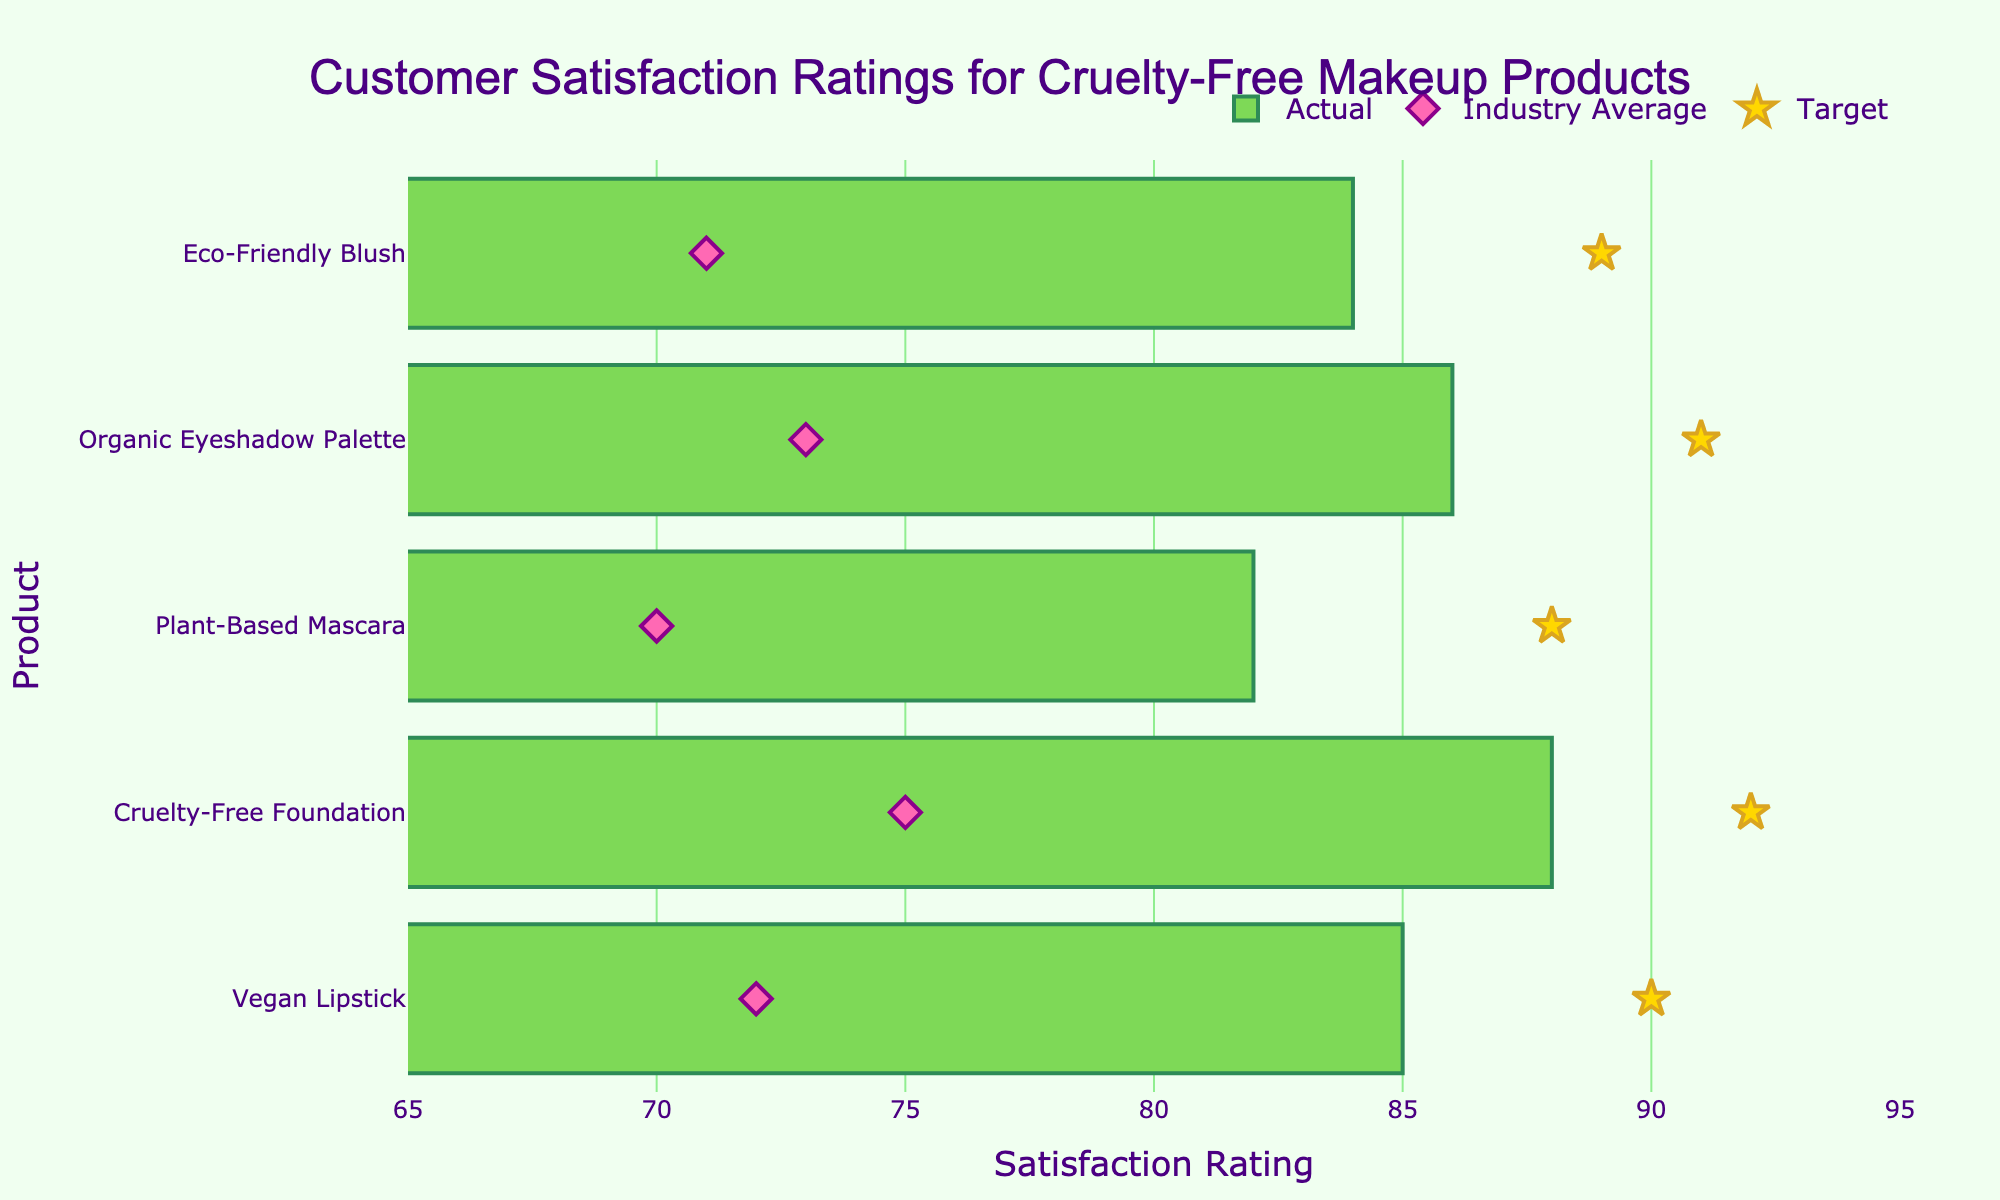What's the title of the figure? The title is usually located at the top center of the figure. It helps identify the main subject of the chart. In this case, it is "Customer Satisfaction Ratings for Cruelty-Free Makeup Products".
Answer: Customer Satisfaction Ratings for Cruelty-Free Makeup Products What is the highest actual satisfaction rating among the products? To find the highest actual satisfaction rating, we need to look at the longest bar in the chart, which corresponds to the "Cruelty-Free Foundation" with a rating of 88.
Answer: 88 Which product has the lowest industry average satisfaction rating? The industry average satisfaction ratings are represented by the diamond markers in the figure. The lowest marker is for "Plant-Based Mascara" with a rating of 70.
Answer: Plant-Based Mascara How does the satisfaction rating of Vegan Lipstick compare to its target? We can compare the actual bar height (85) and the star marker (90) to see that the satisfaction rating for Vegan Lipstick is slightly below its target.
Answer: Below target by 5 points Which product has the smallest gap between its actual satisfaction rating and its target? To determine the smallest gap, we calculate the absolute differences between the actual ratings and the target ratings for each product. The smallest difference is 3 points for "Eco-Friendly Blush" (84 actual vs. 89 target).
Answer: Eco-Friendly Blush What is the average actual satisfaction rating of the products? Adding up all the actual ratings (85, 88, 82, 86, 84) gives us 425. Dividing by the number of products (5) gives an average of 85.
Answer: 85 Which product's industry average is closest to its target? Compare the industry averages (diamond markers) to the target markers (stars) and find the smallest difference. "Plant-Based Mascara" has a rating of 70 (industry average) and 88 (target), which is an 18-point difference, the closest among all products.
Answer: Plant-Based Mascara How many products have an actual satisfaction rating above the industry average? Count the bars whose lengths (actual ratings) are above the respective diamond markers (industry averages). All products (Vegan Lipstick, Cruelty-Free Foundation, Plant-Based Mascara, Organic Eyeshadow Palette, Eco-Friendly Blush) have higher actual ratings than the industry average.
Answer: 5 Which product needs the most improvement to meet its target? The product with the largest gap between its actual satisfaction rating and target is "Plant-Based Mascara" (82 actual vs. 88 target), needing an improvement of 6 points.
Answer: Plant-Based Mascara 